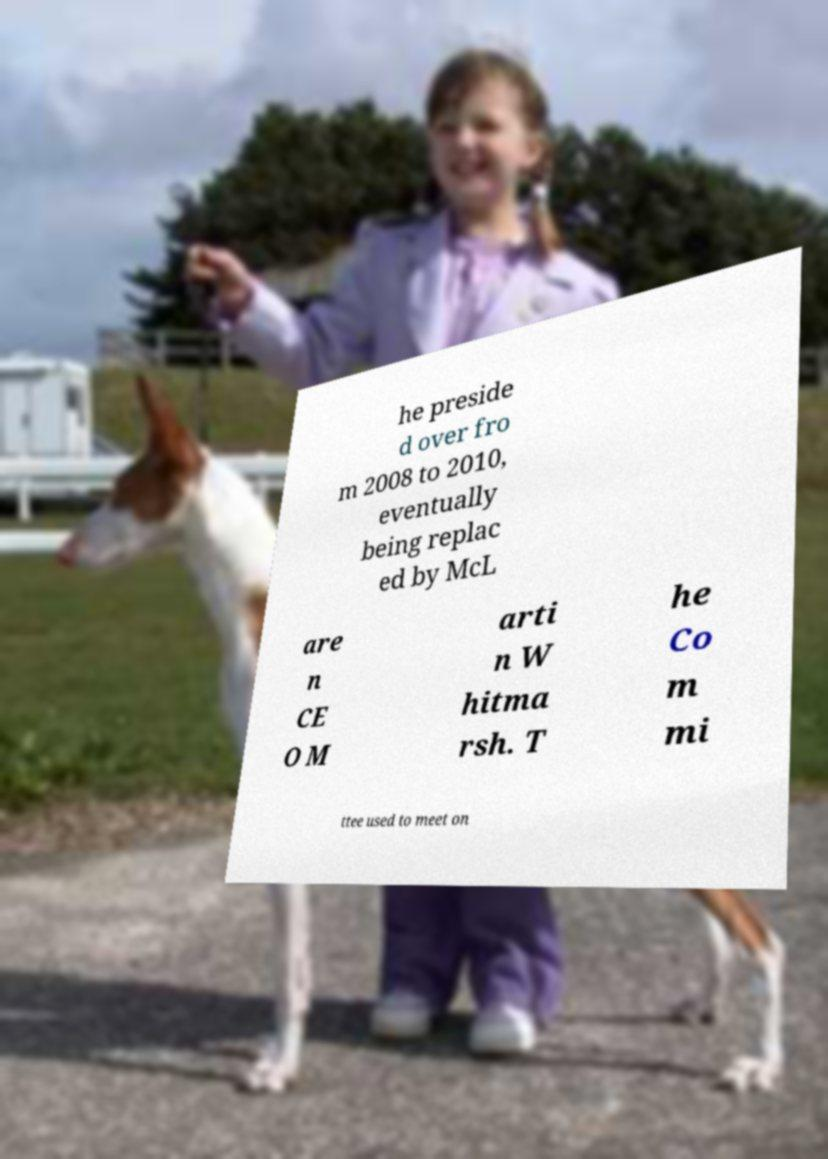There's text embedded in this image that I need extracted. Can you transcribe it verbatim? he preside d over fro m 2008 to 2010, eventually being replac ed by McL are n CE O M arti n W hitma rsh. T he Co m mi ttee used to meet on 